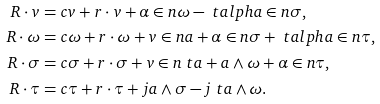Convert formula to latex. <formula><loc_0><loc_0><loc_500><loc_500>R \cdot v & = c v + r \cdot v + \alpha \in n \omega - \ t a l p h a \in n \sigma , \\ R \cdot \omega & = c \omega + r \cdot \omega + v \in n a + \alpha \in n \sigma + \ t a l p h a \in n \tau , \\ R \cdot \sigma & = c \sigma + r \cdot \sigma + v \in n \ t a + a \wedge \omega + \alpha \in n \tau , \\ R \cdot \tau & = c \tau + r \cdot \tau + j a \wedge \sigma - j \ t a \wedge \omega .</formula> 